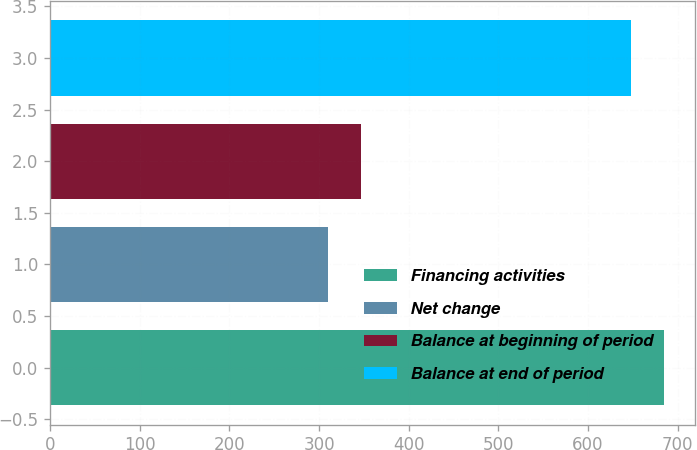Convert chart to OTSL. <chart><loc_0><loc_0><loc_500><loc_500><bar_chart><fcel>Financing activities<fcel>Net change<fcel>Balance at beginning of period<fcel>Balance at end of period<nl><fcel>684.7<fcel>310<fcel>346.7<fcel>648<nl></chart> 